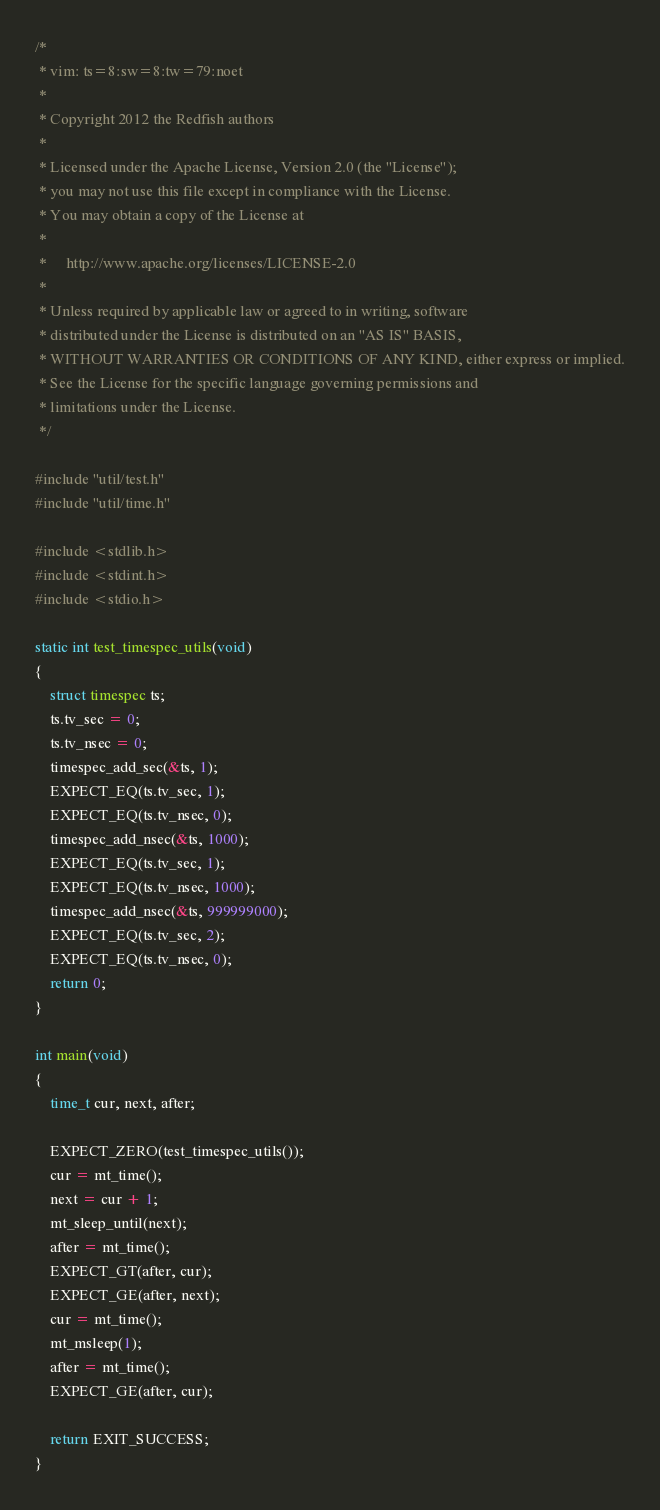Convert code to text. <code><loc_0><loc_0><loc_500><loc_500><_C_>/*
 * vim: ts=8:sw=8:tw=79:noet
 * 
 * Copyright 2012 the Redfish authors
 *
 * Licensed under the Apache License, Version 2.0 (the "License");
 * you may not use this file except in compliance with the License.
 * You may obtain a copy of the License at
 *
 *     http://www.apache.org/licenses/LICENSE-2.0
 *
 * Unless required by applicable law or agreed to in writing, software
 * distributed under the License is distributed on an "AS IS" BASIS,
 * WITHOUT WARRANTIES OR CONDITIONS OF ANY KIND, either express or implied.
 * See the License for the specific language governing permissions and
 * limitations under the License.
 */

#include "util/test.h"
#include "util/time.h"

#include <stdlib.h>
#include <stdint.h>
#include <stdio.h>

static int test_timespec_utils(void)
{
	struct timespec ts;
	ts.tv_sec = 0;
	ts.tv_nsec = 0;
	timespec_add_sec(&ts, 1);
	EXPECT_EQ(ts.tv_sec, 1);
	EXPECT_EQ(ts.tv_nsec, 0);
	timespec_add_nsec(&ts, 1000);
	EXPECT_EQ(ts.tv_sec, 1);
	EXPECT_EQ(ts.tv_nsec, 1000);
	timespec_add_nsec(&ts, 999999000);
	EXPECT_EQ(ts.tv_sec, 2);
	EXPECT_EQ(ts.tv_nsec, 0);
	return 0;
}

int main(void)
{
	time_t cur, next, after;

	EXPECT_ZERO(test_timespec_utils());
	cur = mt_time();
	next = cur + 1;
	mt_sleep_until(next);
	after = mt_time();
	EXPECT_GT(after, cur);
	EXPECT_GE(after, next);
	cur = mt_time();
	mt_msleep(1);
	after = mt_time();
	EXPECT_GE(after, cur);

	return EXIT_SUCCESS;
}
</code> 